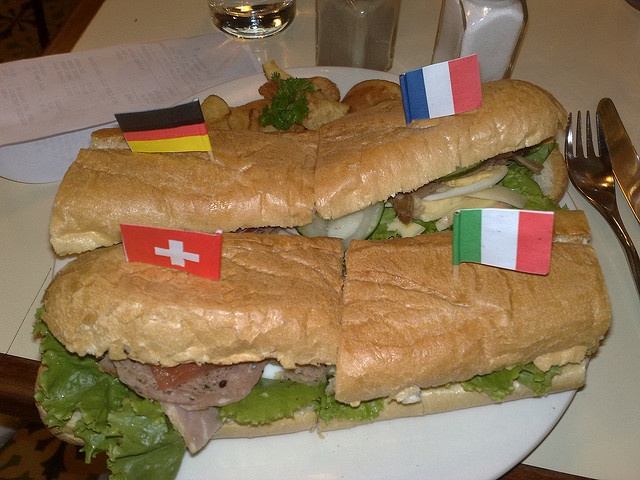Describe the objects in this image and their specific colors. I can see dining table in black, tan, gray, and olive tones, sandwich in black, darkgreen, tan, gray, and olive tones, sandwich in black, tan, and olive tones, sandwich in black, olive, and tan tones, and dining table in black, gray, and maroon tones in this image. 